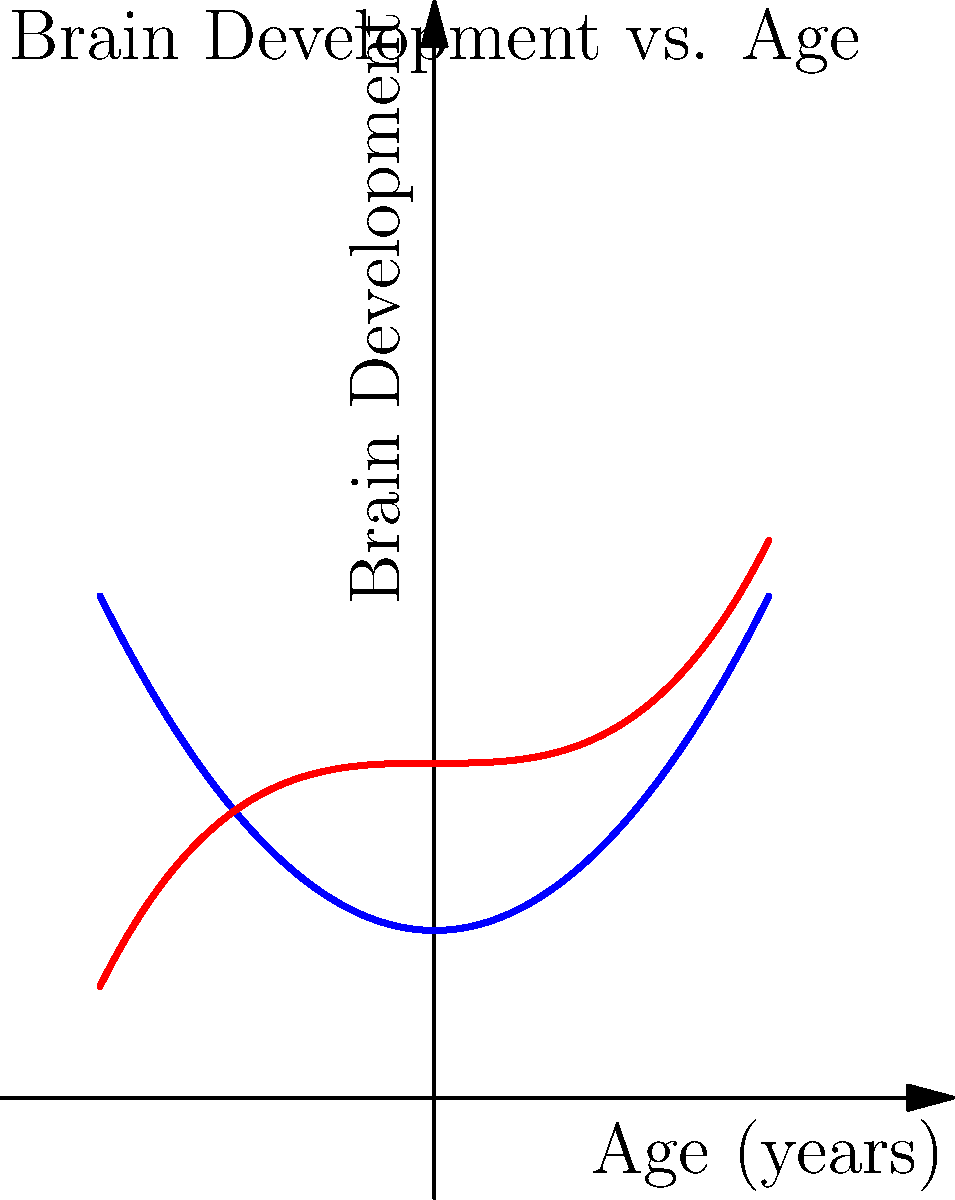The graph above shows brain development curves for children in neglectful (blue) and nurturing (red) environments. Based on this information, which of the following statements is most accurate regarding the impact of a nurturing environment on brain development?

A) Nurturing environments have no significant impact on brain development
B) Nurturing environments lead to faster brain development in early years but plateau quickly
C) Nurturing environments result in consistently higher rates of brain development over time
D) Nurturing environments only impact brain development after age 2 To answer this question, let's analyze the graph step-by-step:

1. The blue curve represents brain development in a neglectful environment, while the red curve represents development in a nurturing environment.

2. Observe that both curves start at a similar point, indicating similar initial brain development.

3. As age increases (moving right on the x-axis), we can see that:
   a) The red curve (nurturing environment) rises more steeply than the blue curve.
   b) The gap between the two curves widens over time.

4. The red curve maintains a higher position and steeper slope throughout the entire graph, indicating:
   a) Consistently higher levels of brain development in nurturing environments.
   b) A faster rate of development that continues over time.

5. There is no plateau visible in the red curve, suggesting that the positive effects of a nurturing environment continue throughout the age range shown.

6. The difference between the curves is apparent from the beginning, not just after age 2.

Given these observations, the statement that best describes the impact of a nurturing environment on brain development is:

C) Nurturing environments result in consistently higher rates of brain development over time.

This answer accurately reflects the continuous, positive influence of nurturing environments on brain development as illustrated in the graph.
Answer: C) Nurturing environments result in consistently higher rates of brain development over time. 